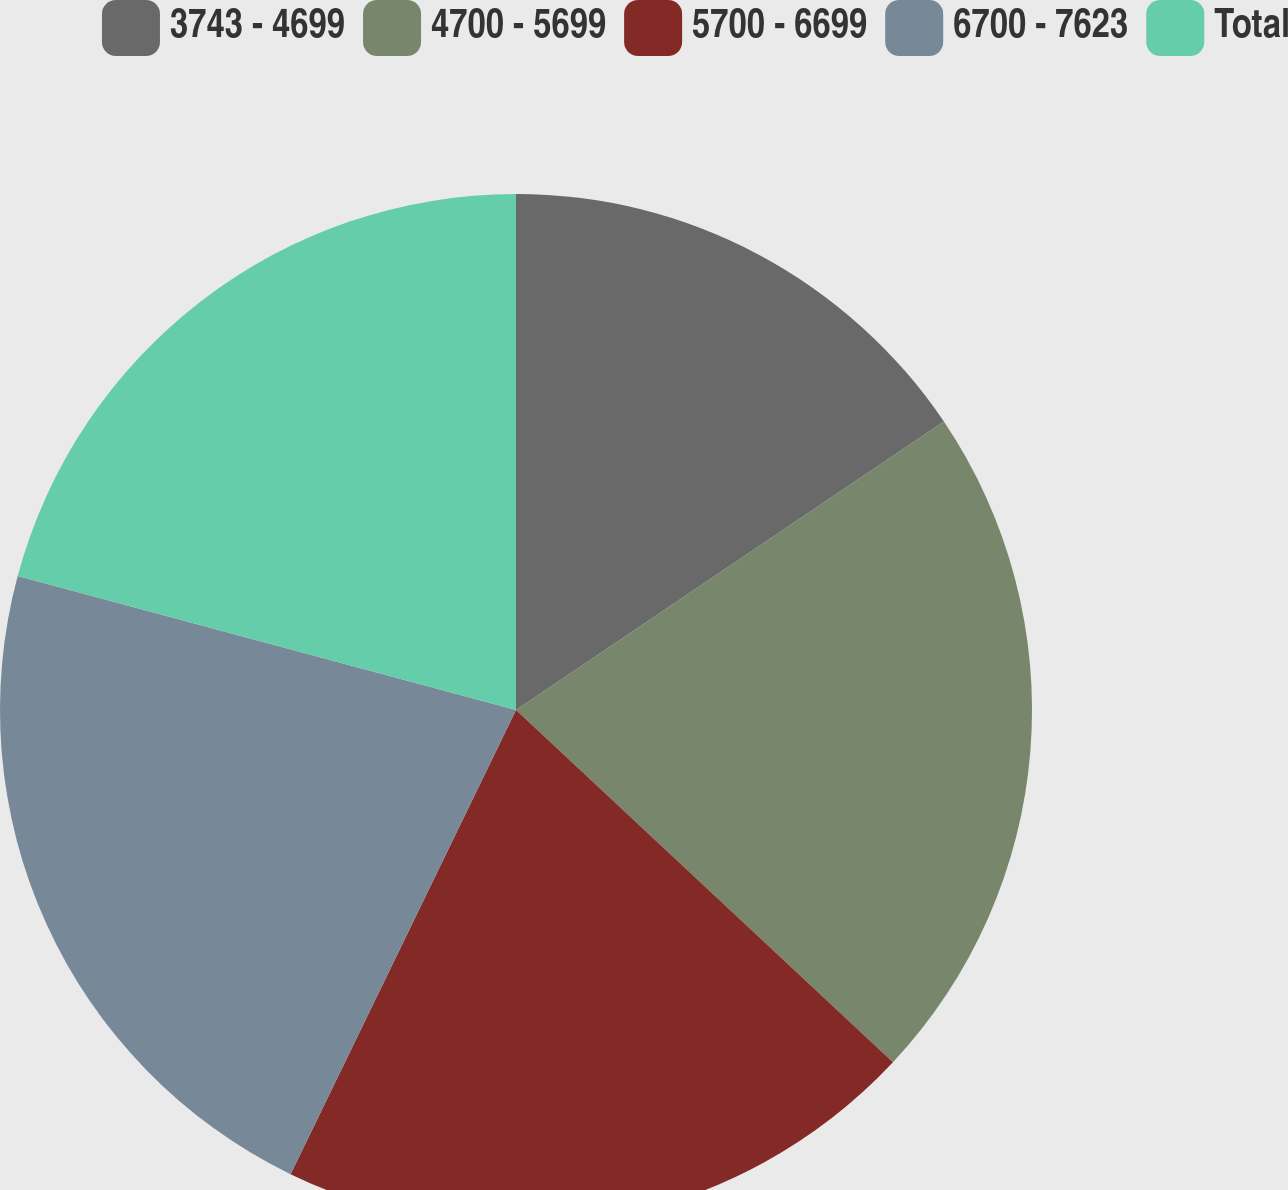<chart> <loc_0><loc_0><loc_500><loc_500><pie_chart><fcel>3743 - 4699<fcel>4700 - 5699<fcel>5700 - 6699<fcel>6700 - 7623<fcel>Total<nl><fcel>15.56%<fcel>21.4%<fcel>20.23%<fcel>21.98%<fcel>20.82%<nl></chart> 